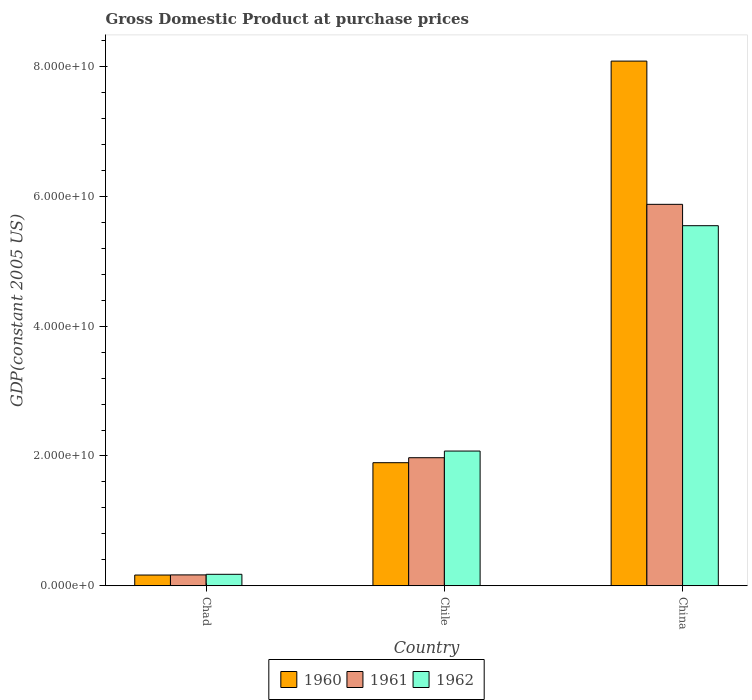How many groups of bars are there?
Your answer should be compact. 3. Are the number of bars per tick equal to the number of legend labels?
Your response must be concise. Yes. How many bars are there on the 3rd tick from the right?
Ensure brevity in your answer.  3. What is the label of the 2nd group of bars from the left?
Your response must be concise. Chile. What is the GDP at purchase prices in 1962 in China?
Offer a very short reply. 5.55e+1. Across all countries, what is the maximum GDP at purchase prices in 1961?
Your response must be concise. 5.88e+1. Across all countries, what is the minimum GDP at purchase prices in 1960?
Your answer should be compact. 1.65e+09. In which country was the GDP at purchase prices in 1962 minimum?
Offer a very short reply. Chad. What is the total GDP at purchase prices in 1960 in the graph?
Make the answer very short. 1.01e+11. What is the difference between the GDP at purchase prices in 1960 in Chad and that in Chile?
Your answer should be compact. -1.73e+1. What is the difference between the GDP at purchase prices in 1960 in China and the GDP at purchase prices in 1962 in Chile?
Offer a very short reply. 6.01e+1. What is the average GDP at purchase prices in 1962 per country?
Keep it short and to the point. 2.60e+1. What is the difference between the GDP at purchase prices of/in 1960 and GDP at purchase prices of/in 1961 in China?
Give a very brief answer. 2.21e+1. In how many countries, is the GDP at purchase prices in 1961 greater than 4000000000 US$?
Provide a succinct answer. 2. What is the ratio of the GDP at purchase prices in 1962 in Chad to that in Chile?
Your answer should be very brief. 0.09. Is the difference between the GDP at purchase prices in 1960 in Chile and China greater than the difference between the GDP at purchase prices in 1961 in Chile and China?
Make the answer very short. No. What is the difference between the highest and the second highest GDP at purchase prices in 1962?
Make the answer very short. 5.37e+1. What is the difference between the highest and the lowest GDP at purchase prices in 1960?
Ensure brevity in your answer.  7.92e+1. In how many countries, is the GDP at purchase prices in 1962 greater than the average GDP at purchase prices in 1962 taken over all countries?
Keep it short and to the point. 1. What does the 3rd bar from the right in Chad represents?
Your answer should be compact. 1960. Are all the bars in the graph horizontal?
Offer a terse response. No. How many countries are there in the graph?
Your response must be concise. 3. What is the difference between two consecutive major ticks on the Y-axis?
Give a very brief answer. 2.00e+1. Are the values on the major ticks of Y-axis written in scientific E-notation?
Ensure brevity in your answer.  Yes. Does the graph contain any zero values?
Ensure brevity in your answer.  No. Does the graph contain grids?
Give a very brief answer. No. How many legend labels are there?
Offer a very short reply. 3. What is the title of the graph?
Offer a terse response. Gross Domestic Product at purchase prices. Does "1960" appear as one of the legend labels in the graph?
Your answer should be compact. Yes. What is the label or title of the Y-axis?
Provide a short and direct response. GDP(constant 2005 US). What is the GDP(constant 2005 US) in 1960 in Chad?
Make the answer very short. 1.65e+09. What is the GDP(constant 2005 US) in 1961 in Chad?
Ensure brevity in your answer.  1.68e+09. What is the GDP(constant 2005 US) in 1962 in Chad?
Provide a succinct answer. 1.77e+09. What is the GDP(constant 2005 US) of 1960 in Chile?
Offer a very short reply. 1.90e+1. What is the GDP(constant 2005 US) of 1961 in Chile?
Offer a very short reply. 1.97e+1. What is the GDP(constant 2005 US) in 1962 in Chile?
Provide a short and direct response. 2.08e+1. What is the GDP(constant 2005 US) of 1960 in China?
Provide a succinct answer. 8.08e+1. What is the GDP(constant 2005 US) in 1961 in China?
Provide a short and direct response. 5.88e+1. What is the GDP(constant 2005 US) in 1962 in China?
Provide a short and direct response. 5.55e+1. Across all countries, what is the maximum GDP(constant 2005 US) in 1960?
Your response must be concise. 8.08e+1. Across all countries, what is the maximum GDP(constant 2005 US) of 1961?
Provide a short and direct response. 5.88e+1. Across all countries, what is the maximum GDP(constant 2005 US) of 1962?
Offer a very short reply. 5.55e+1. Across all countries, what is the minimum GDP(constant 2005 US) in 1960?
Offer a terse response. 1.65e+09. Across all countries, what is the minimum GDP(constant 2005 US) of 1961?
Offer a very short reply. 1.68e+09. Across all countries, what is the minimum GDP(constant 2005 US) of 1962?
Provide a succinct answer. 1.77e+09. What is the total GDP(constant 2005 US) in 1960 in the graph?
Keep it short and to the point. 1.01e+11. What is the total GDP(constant 2005 US) in 1961 in the graph?
Provide a succinct answer. 8.02e+1. What is the total GDP(constant 2005 US) in 1962 in the graph?
Provide a short and direct response. 7.80e+1. What is the difference between the GDP(constant 2005 US) in 1960 in Chad and that in Chile?
Keep it short and to the point. -1.73e+1. What is the difference between the GDP(constant 2005 US) of 1961 in Chad and that in Chile?
Keep it short and to the point. -1.81e+1. What is the difference between the GDP(constant 2005 US) of 1962 in Chad and that in Chile?
Offer a terse response. -1.90e+1. What is the difference between the GDP(constant 2005 US) of 1960 in Chad and that in China?
Make the answer very short. -7.92e+1. What is the difference between the GDP(constant 2005 US) of 1961 in Chad and that in China?
Ensure brevity in your answer.  -5.71e+1. What is the difference between the GDP(constant 2005 US) of 1962 in Chad and that in China?
Ensure brevity in your answer.  -5.37e+1. What is the difference between the GDP(constant 2005 US) in 1960 in Chile and that in China?
Give a very brief answer. -6.19e+1. What is the difference between the GDP(constant 2005 US) of 1961 in Chile and that in China?
Provide a short and direct response. -3.90e+1. What is the difference between the GDP(constant 2005 US) of 1962 in Chile and that in China?
Ensure brevity in your answer.  -3.47e+1. What is the difference between the GDP(constant 2005 US) of 1960 in Chad and the GDP(constant 2005 US) of 1961 in Chile?
Your answer should be very brief. -1.81e+1. What is the difference between the GDP(constant 2005 US) in 1960 in Chad and the GDP(constant 2005 US) in 1962 in Chile?
Your answer should be compact. -1.91e+1. What is the difference between the GDP(constant 2005 US) of 1961 in Chad and the GDP(constant 2005 US) of 1962 in Chile?
Offer a terse response. -1.91e+1. What is the difference between the GDP(constant 2005 US) in 1960 in Chad and the GDP(constant 2005 US) in 1961 in China?
Provide a short and direct response. -5.71e+1. What is the difference between the GDP(constant 2005 US) of 1960 in Chad and the GDP(constant 2005 US) of 1962 in China?
Provide a succinct answer. -5.38e+1. What is the difference between the GDP(constant 2005 US) of 1961 in Chad and the GDP(constant 2005 US) of 1962 in China?
Your answer should be compact. -5.38e+1. What is the difference between the GDP(constant 2005 US) of 1960 in Chile and the GDP(constant 2005 US) of 1961 in China?
Ensure brevity in your answer.  -3.98e+1. What is the difference between the GDP(constant 2005 US) of 1960 in Chile and the GDP(constant 2005 US) of 1962 in China?
Make the answer very short. -3.65e+1. What is the difference between the GDP(constant 2005 US) of 1961 in Chile and the GDP(constant 2005 US) of 1962 in China?
Ensure brevity in your answer.  -3.58e+1. What is the average GDP(constant 2005 US) of 1960 per country?
Make the answer very short. 3.38e+1. What is the average GDP(constant 2005 US) in 1961 per country?
Provide a succinct answer. 2.67e+1. What is the average GDP(constant 2005 US) in 1962 per country?
Keep it short and to the point. 2.60e+1. What is the difference between the GDP(constant 2005 US) in 1960 and GDP(constant 2005 US) in 1961 in Chad?
Ensure brevity in your answer.  -2.31e+07. What is the difference between the GDP(constant 2005 US) of 1960 and GDP(constant 2005 US) of 1962 in Chad?
Offer a terse response. -1.13e+08. What is the difference between the GDP(constant 2005 US) of 1961 and GDP(constant 2005 US) of 1962 in Chad?
Offer a terse response. -8.98e+07. What is the difference between the GDP(constant 2005 US) of 1960 and GDP(constant 2005 US) of 1961 in Chile?
Provide a succinct answer. -7.68e+08. What is the difference between the GDP(constant 2005 US) of 1960 and GDP(constant 2005 US) of 1962 in Chile?
Your answer should be compact. -1.79e+09. What is the difference between the GDP(constant 2005 US) in 1961 and GDP(constant 2005 US) in 1962 in Chile?
Keep it short and to the point. -1.02e+09. What is the difference between the GDP(constant 2005 US) of 1960 and GDP(constant 2005 US) of 1961 in China?
Your answer should be compact. 2.21e+1. What is the difference between the GDP(constant 2005 US) of 1960 and GDP(constant 2005 US) of 1962 in China?
Provide a short and direct response. 2.54e+1. What is the difference between the GDP(constant 2005 US) of 1961 and GDP(constant 2005 US) of 1962 in China?
Make the answer very short. 3.29e+09. What is the ratio of the GDP(constant 2005 US) of 1960 in Chad to that in Chile?
Give a very brief answer. 0.09. What is the ratio of the GDP(constant 2005 US) in 1961 in Chad to that in Chile?
Make the answer very short. 0.08. What is the ratio of the GDP(constant 2005 US) in 1962 in Chad to that in Chile?
Offer a very short reply. 0.09. What is the ratio of the GDP(constant 2005 US) in 1960 in Chad to that in China?
Your answer should be compact. 0.02. What is the ratio of the GDP(constant 2005 US) of 1961 in Chad to that in China?
Give a very brief answer. 0.03. What is the ratio of the GDP(constant 2005 US) of 1962 in Chad to that in China?
Make the answer very short. 0.03. What is the ratio of the GDP(constant 2005 US) of 1960 in Chile to that in China?
Offer a terse response. 0.23. What is the ratio of the GDP(constant 2005 US) of 1961 in Chile to that in China?
Your response must be concise. 0.34. What is the ratio of the GDP(constant 2005 US) of 1962 in Chile to that in China?
Offer a very short reply. 0.37. What is the difference between the highest and the second highest GDP(constant 2005 US) of 1960?
Provide a short and direct response. 6.19e+1. What is the difference between the highest and the second highest GDP(constant 2005 US) in 1961?
Your response must be concise. 3.90e+1. What is the difference between the highest and the second highest GDP(constant 2005 US) in 1962?
Make the answer very short. 3.47e+1. What is the difference between the highest and the lowest GDP(constant 2005 US) of 1960?
Offer a very short reply. 7.92e+1. What is the difference between the highest and the lowest GDP(constant 2005 US) of 1961?
Your response must be concise. 5.71e+1. What is the difference between the highest and the lowest GDP(constant 2005 US) of 1962?
Your answer should be very brief. 5.37e+1. 